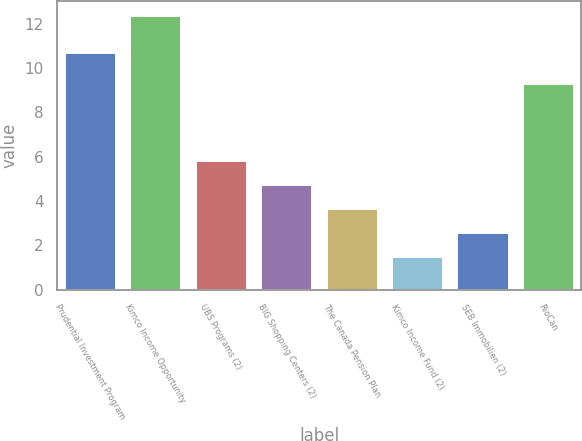Convert chart to OTSL. <chart><loc_0><loc_0><loc_500><loc_500><bar_chart><fcel>Prudential Investment Program<fcel>Kimco Income Opportunity<fcel>UBS Programs (2)<fcel>BIG Shopping Centers (2)<fcel>The Canada Pension Plan<fcel>Kimco Income Fund (2)<fcel>SEB Immobilien (2)<fcel>RioCan<nl><fcel>10.7<fcel>12.4<fcel>5.86<fcel>4.77<fcel>3.68<fcel>1.5<fcel>2.59<fcel>9.3<nl></chart> 